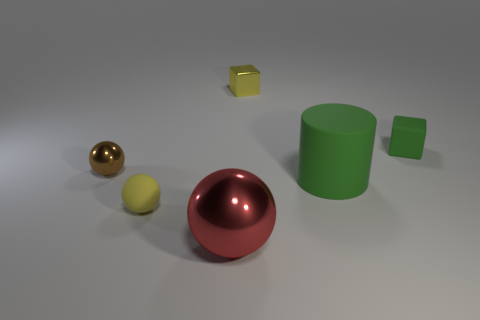Add 1 large green matte cylinders. How many objects exist? 7 Subtract all blocks. How many objects are left? 4 Subtract all spheres. Subtract all big red objects. How many objects are left? 2 Add 1 brown metallic objects. How many brown metallic objects are left? 2 Add 6 large yellow shiny things. How many large yellow shiny things exist? 6 Subtract 0 cyan blocks. How many objects are left? 6 